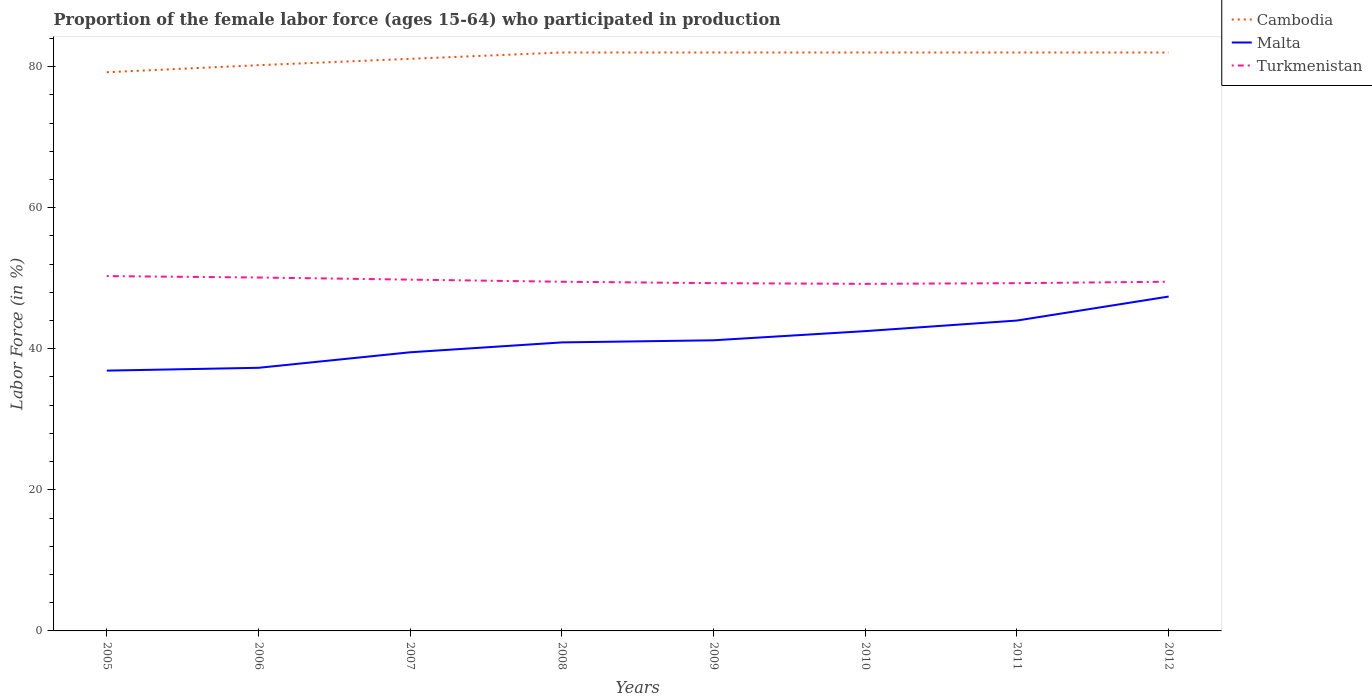How many different coloured lines are there?
Provide a succinct answer. 3. Across all years, what is the maximum proportion of the female labor force who participated in production in Malta?
Provide a short and direct response. 36.9. What is the total proportion of the female labor force who participated in production in Malta in the graph?
Your response must be concise. -1.5. What is the difference between the highest and the second highest proportion of the female labor force who participated in production in Malta?
Your answer should be very brief. 10.5. How many years are there in the graph?
Your answer should be very brief. 8. Does the graph contain grids?
Your response must be concise. No. How are the legend labels stacked?
Provide a succinct answer. Vertical. What is the title of the graph?
Your answer should be very brief. Proportion of the female labor force (ages 15-64) who participated in production. Does "Nicaragua" appear as one of the legend labels in the graph?
Provide a succinct answer. No. What is the label or title of the Y-axis?
Your answer should be compact. Labor Force (in %). What is the Labor Force (in %) in Cambodia in 2005?
Make the answer very short. 79.2. What is the Labor Force (in %) in Malta in 2005?
Make the answer very short. 36.9. What is the Labor Force (in %) of Turkmenistan in 2005?
Your answer should be very brief. 50.3. What is the Labor Force (in %) of Cambodia in 2006?
Ensure brevity in your answer.  80.2. What is the Labor Force (in %) in Malta in 2006?
Provide a succinct answer. 37.3. What is the Labor Force (in %) of Turkmenistan in 2006?
Ensure brevity in your answer.  50.1. What is the Labor Force (in %) of Cambodia in 2007?
Ensure brevity in your answer.  81.1. What is the Labor Force (in %) of Malta in 2007?
Your response must be concise. 39.5. What is the Labor Force (in %) in Turkmenistan in 2007?
Your answer should be very brief. 49.8. What is the Labor Force (in %) in Malta in 2008?
Ensure brevity in your answer.  40.9. What is the Labor Force (in %) of Turkmenistan in 2008?
Your response must be concise. 49.5. What is the Labor Force (in %) of Cambodia in 2009?
Offer a very short reply. 82. What is the Labor Force (in %) of Malta in 2009?
Keep it short and to the point. 41.2. What is the Labor Force (in %) of Turkmenistan in 2009?
Give a very brief answer. 49.3. What is the Labor Force (in %) in Cambodia in 2010?
Your response must be concise. 82. What is the Labor Force (in %) of Malta in 2010?
Your answer should be very brief. 42.5. What is the Labor Force (in %) of Turkmenistan in 2010?
Provide a short and direct response. 49.2. What is the Labor Force (in %) of Cambodia in 2011?
Provide a short and direct response. 82. What is the Labor Force (in %) of Malta in 2011?
Give a very brief answer. 44. What is the Labor Force (in %) of Turkmenistan in 2011?
Offer a terse response. 49.3. What is the Labor Force (in %) in Cambodia in 2012?
Give a very brief answer. 82. What is the Labor Force (in %) in Malta in 2012?
Provide a succinct answer. 47.4. What is the Labor Force (in %) in Turkmenistan in 2012?
Make the answer very short. 49.5. Across all years, what is the maximum Labor Force (in %) of Cambodia?
Your answer should be very brief. 82. Across all years, what is the maximum Labor Force (in %) in Malta?
Your response must be concise. 47.4. Across all years, what is the maximum Labor Force (in %) of Turkmenistan?
Keep it short and to the point. 50.3. Across all years, what is the minimum Labor Force (in %) in Cambodia?
Provide a succinct answer. 79.2. Across all years, what is the minimum Labor Force (in %) of Malta?
Keep it short and to the point. 36.9. Across all years, what is the minimum Labor Force (in %) of Turkmenistan?
Give a very brief answer. 49.2. What is the total Labor Force (in %) of Cambodia in the graph?
Provide a short and direct response. 650.5. What is the total Labor Force (in %) of Malta in the graph?
Keep it short and to the point. 329.7. What is the total Labor Force (in %) of Turkmenistan in the graph?
Keep it short and to the point. 397. What is the difference between the Labor Force (in %) of Cambodia in 2005 and that in 2006?
Provide a short and direct response. -1. What is the difference between the Labor Force (in %) in Malta in 2005 and that in 2006?
Provide a short and direct response. -0.4. What is the difference between the Labor Force (in %) in Malta in 2005 and that in 2008?
Your answer should be compact. -4. What is the difference between the Labor Force (in %) of Cambodia in 2005 and that in 2009?
Your answer should be very brief. -2.8. What is the difference between the Labor Force (in %) of Turkmenistan in 2005 and that in 2009?
Make the answer very short. 1. What is the difference between the Labor Force (in %) in Cambodia in 2005 and that in 2010?
Your answer should be very brief. -2.8. What is the difference between the Labor Force (in %) of Malta in 2005 and that in 2010?
Offer a very short reply. -5.6. What is the difference between the Labor Force (in %) of Cambodia in 2005 and that in 2011?
Give a very brief answer. -2.8. What is the difference between the Labor Force (in %) of Malta in 2005 and that in 2011?
Provide a short and direct response. -7.1. What is the difference between the Labor Force (in %) in Malta in 2005 and that in 2012?
Your response must be concise. -10.5. What is the difference between the Labor Force (in %) of Malta in 2006 and that in 2007?
Make the answer very short. -2.2. What is the difference between the Labor Force (in %) of Malta in 2006 and that in 2009?
Provide a short and direct response. -3.9. What is the difference between the Labor Force (in %) of Malta in 2006 and that in 2010?
Make the answer very short. -5.2. What is the difference between the Labor Force (in %) of Turkmenistan in 2006 and that in 2010?
Give a very brief answer. 0.9. What is the difference between the Labor Force (in %) in Cambodia in 2006 and that in 2011?
Your answer should be very brief. -1.8. What is the difference between the Labor Force (in %) in Malta in 2006 and that in 2011?
Keep it short and to the point. -6.7. What is the difference between the Labor Force (in %) of Malta in 2006 and that in 2012?
Ensure brevity in your answer.  -10.1. What is the difference between the Labor Force (in %) of Cambodia in 2007 and that in 2008?
Offer a terse response. -0.9. What is the difference between the Labor Force (in %) of Cambodia in 2007 and that in 2009?
Offer a terse response. -0.9. What is the difference between the Labor Force (in %) in Cambodia in 2007 and that in 2010?
Ensure brevity in your answer.  -0.9. What is the difference between the Labor Force (in %) of Malta in 2007 and that in 2010?
Provide a short and direct response. -3. What is the difference between the Labor Force (in %) in Turkmenistan in 2007 and that in 2010?
Keep it short and to the point. 0.6. What is the difference between the Labor Force (in %) in Cambodia in 2007 and that in 2011?
Your answer should be compact. -0.9. What is the difference between the Labor Force (in %) in Malta in 2007 and that in 2011?
Ensure brevity in your answer.  -4.5. What is the difference between the Labor Force (in %) in Turkmenistan in 2007 and that in 2011?
Make the answer very short. 0.5. What is the difference between the Labor Force (in %) of Cambodia in 2007 and that in 2012?
Offer a very short reply. -0.9. What is the difference between the Labor Force (in %) in Malta in 2007 and that in 2012?
Make the answer very short. -7.9. What is the difference between the Labor Force (in %) of Turkmenistan in 2007 and that in 2012?
Provide a succinct answer. 0.3. What is the difference between the Labor Force (in %) of Cambodia in 2008 and that in 2009?
Offer a terse response. 0. What is the difference between the Labor Force (in %) in Malta in 2008 and that in 2009?
Your answer should be compact. -0.3. What is the difference between the Labor Force (in %) in Turkmenistan in 2008 and that in 2009?
Your response must be concise. 0.2. What is the difference between the Labor Force (in %) in Cambodia in 2008 and that in 2010?
Offer a very short reply. 0. What is the difference between the Labor Force (in %) in Malta in 2008 and that in 2010?
Provide a succinct answer. -1.6. What is the difference between the Labor Force (in %) in Cambodia in 2008 and that in 2011?
Your answer should be compact. 0. What is the difference between the Labor Force (in %) in Malta in 2008 and that in 2011?
Your response must be concise. -3.1. What is the difference between the Labor Force (in %) of Turkmenistan in 2008 and that in 2011?
Make the answer very short. 0.2. What is the difference between the Labor Force (in %) of Malta in 2008 and that in 2012?
Make the answer very short. -6.5. What is the difference between the Labor Force (in %) of Cambodia in 2009 and that in 2010?
Keep it short and to the point. 0. What is the difference between the Labor Force (in %) of Malta in 2009 and that in 2010?
Your response must be concise. -1.3. What is the difference between the Labor Force (in %) of Malta in 2009 and that in 2011?
Your answer should be very brief. -2.8. What is the difference between the Labor Force (in %) in Cambodia in 2009 and that in 2012?
Offer a very short reply. 0. What is the difference between the Labor Force (in %) of Malta in 2009 and that in 2012?
Offer a terse response. -6.2. What is the difference between the Labor Force (in %) of Turkmenistan in 2009 and that in 2012?
Your response must be concise. -0.2. What is the difference between the Labor Force (in %) of Turkmenistan in 2010 and that in 2011?
Provide a succinct answer. -0.1. What is the difference between the Labor Force (in %) of Cambodia in 2010 and that in 2012?
Give a very brief answer. 0. What is the difference between the Labor Force (in %) in Malta in 2011 and that in 2012?
Provide a short and direct response. -3.4. What is the difference between the Labor Force (in %) in Cambodia in 2005 and the Labor Force (in %) in Malta in 2006?
Ensure brevity in your answer.  41.9. What is the difference between the Labor Force (in %) of Cambodia in 2005 and the Labor Force (in %) of Turkmenistan in 2006?
Your response must be concise. 29.1. What is the difference between the Labor Force (in %) of Cambodia in 2005 and the Labor Force (in %) of Malta in 2007?
Offer a terse response. 39.7. What is the difference between the Labor Force (in %) of Cambodia in 2005 and the Labor Force (in %) of Turkmenistan in 2007?
Your answer should be compact. 29.4. What is the difference between the Labor Force (in %) of Malta in 2005 and the Labor Force (in %) of Turkmenistan in 2007?
Ensure brevity in your answer.  -12.9. What is the difference between the Labor Force (in %) in Cambodia in 2005 and the Labor Force (in %) in Malta in 2008?
Offer a terse response. 38.3. What is the difference between the Labor Force (in %) in Cambodia in 2005 and the Labor Force (in %) in Turkmenistan in 2008?
Make the answer very short. 29.7. What is the difference between the Labor Force (in %) of Cambodia in 2005 and the Labor Force (in %) of Malta in 2009?
Give a very brief answer. 38. What is the difference between the Labor Force (in %) of Cambodia in 2005 and the Labor Force (in %) of Turkmenistan in 2009?
Offer a terse response. 29.9. What is the difference between the Labor Force (in %) in Malta in 2005 and the Labor Force (in %) in Turkmenistan in 2009?
Keep it short and to the point. -12.4. What is the difference between the Labor Force (in %) of Cambodia in 2005 and the Labor Force (in %) of Malta in 2010?
Make the answer very short. 36.7. What is the difference between the Labor Force (in %) in Cambodia in 2005 and the Labor Force (in %) in Turkmenistan in 2010?
Provide a short and direct response. 30. What is the difference between the Labor Force (in %) in Cambodia in 2005 and the Labor Force (in %) in Malta in 2011?
Keep it short and to the point. 35.2. What is the difference between the Labor Force (in %) of Cambodia in 2005 and the Labor Force (in %) of Turkmenistan in 2011?
Offer a very short reply. 29.9. What is the difference between the Labor Force (in %) in Cambodia in 2005 and the Labor Force (in %) in Malta in 2012?
Make the answer very short. 31.8. What is the difference between the Labor Force (in %) of Cambodia in 2005 and the Labor Force (in %) of Turkmenistan in 2012?
Offer a very short reply. 29.7. What is the difference between the Labor Force (in %) of Malta in 2005 and the Labor Force (in %) of Turkmenistan in 2012?
Offer a very short reply. -12.6. What is the difference between the Labor Force (in %) of Cambodia in 2006 and the Labor Force (in %) of Malta in 2007?
Offer a very short reply. 40.7. What is the difference between the Labor Force (in %) in Cambodia in 2006 and the Labor Force (in %) in Turkmenistan in 2007?
Make the answer very short. 30.4. What is the difference between the Labor Force (in %) in Malta in 2006 and the Labor Force (in %) in Turkmenistan in 2007?
Offer a terse response. -12.5. What is the difference between the Labor Force (in %) in Cambodia in 2006 and the Labor Force (in %) in Malta in 2008?
Make the answer very short. 39.3. What is the difference between the Labor Force (in %) of Cambodia in 2006 and the Labor Force (in %) of Turkmenistan in 2008?
Provide a short and direct response. 30.7. What is the difference between the Labor Force (in %) in Malta in 2006 and the Labor Force (in %) in Turkmenistan in 2008?
Offer a terse response. -12.2. What is the difference between the Labor Force (in %) of Cambodia in 2006 and the Labor Force (in %) of Malta in 2009?
Give a very brief answer. 39. What is the difference between the Labor Force (in %) of Cambodia in 2006 and the Labor Force (in %) of Turkmenistan in 2009?
Ensure brevity in your answer.  30.9. What is the difference between the Labor Force (in %) in Cambodia in 2006 and the Labor Force (in %) in Malta in 2010?
Make the answer very short. 37.7. What is the difference between the Labor Force (in %) of Cambodia in 2006 and the Labor Force (in %) of Malta in 2011?
Offer a very short reply. 36.2. What is the difference between the Labor Force (in %) in Cambodia in 2006 and the Labor Force (in %) in Turkmenistan in 2011?
Give a very brief answer. 30.9. What is the difference between the Labor Force (in %) of Cambodia in 2006 and the Labor Force (in %) of Malta in 2012?
Give a very brief answer. 32.8. What is the difference between the Labor Force (in %) of Cambodia in 2006 and the Labor Force (in %) of Turkmenistan in 2012?
Your response must be concise. 30.7. What is the difference between the Labor Force (in %) of Malta in 2006 and the Labor Force (in %) of Turkmenistan in 2012?
Your response must be concise. -12.2. What is the difference between the Labor Force (in %) of Cambodia in 2007 and the Labor Force (in %) of Malta in 2008?
Provide a succinct answer. 40.2. What is the difference between the Labor Force (in %) in Cambodia in 2007 and the Labor Force (in %) in Turkmenistan in 2008?
Your response must be concise. 31.6. What is the difference between the Labor Force (in %) of Cambodia in 2007 and the Labor Force (in %) of Malta in 2009?
Your answer should be very brief. 39.9. What is the difference between the Labor Force (in %) in Cambodia in 2007 and the Labor Force (in %) in Turkmenistan in 2009?
Provide a short and direct response. 31.8. What is the difference between the Labor Force (in %) in Malta in 2007 and the Labor Force (in %) in Turkmenistan in 2009?
Your answer should be compact. -9.8. What is the difference between the Labor Force (in %) in Cambodia in 2007 and the Labor Force (in %) in Malta in 2010?
Your response must be concise. 38.6. What is the difference between the Labor Force (in %) in Cambodia in 2007 and the Labor Force (in %) in Turkmenistan in 2010?
Keep it short and to the point. 31.9. What is the difference between the Labor Force (in %) of Malta in 2007 and the Labor Force (in %) of Turkmenistan in 2010?
Offer a terse response. -9.7. What is the difference between the Labor Force (in %) in Cambodia in 2007 and the Labor Force (in %) in Malta in 2011?
Your answer should be compact. 37.1. What is the difference between the Labor Force (in %) of Cambodia in 2007 and the Labor Force (in %) of Turkmenistan in 2011?
Give a very brief answer. 31.8. What is the difference between the Labor Force (in %) in Malta in 2007 and the Labor Force (in %) in Turkmenistan in 2011?
Give a very brief answer. -9.8. What is the difference between the Labor Force (in %) in Cambodia in 2007 and the Labor Force (in %) in Malta in 2012?
Offer a very short reply. 33.7. What is the difference between the Labor Force (in %) of Cambodia in 2007 and the Labor Force (in %) of Turkmenistan in 2012?
Provide a succinct answer. 31.6. What is the difference between the Labor Force (in %) in Cambodia in 2008 and the Labor Force (in %) in Malta in 2009?
Make the answer very short. 40.8. What is the difference between the Labor Force (in %) in Cambodia in 2008 and the Labor Force (in %) in Turkmenistan in 2009?
Ensure brevity in your answer.  32.7. What is the difference between the Labor Force (in %) in Cambodia in 2008 and the Labor Force (in %) in Malta in 2010?
Your response must be concise. 39.5. What is the difference between the Labor Force (in %) of Cambodia in 2008 and the Labor Force (in %) of Turkmenistan in 2010?
Ensure brevity in your answer.  32.8. What is the difference between the Labor Force (in %) in Malta in 2008 and the Labor Force (in %) in Turkmenistan in 2010?
Offer a very short reply. -8.3. What is the difference between the Labor Force (in %) of Cambodia in 2008 and the Labor Force (in %) of Turkmenistan in 2011?
Give a very brief answer. 32.7. What is the difference between the Labor Force (in %) in Malta in 2008 and the Labor Force (in %) in Turkmenistan in 2011?
Keep it short and to the point. -8.4. What is the difference between the Labor Force (in %) in Cambodia in 2008 and the Labor Force (in %) in Malta in 2012?
Provide a succinct answer. 34.6. What is the difference between the Labor Force (in %) of Cambodia in 2008 and the Labor Force (in %) of Turkmenistan in 2012?
Provide a short and direct response. 32.5. What is the difference between the Labor Force (in %) of Malta in 2008 and the Labor Force (in %) of Turkmenistan in 2012?
Provide a succinct answer. -8.6. What is the difference between the Labor Force (in %) of Cambodia in 2009 and the Labor Force (in %) of Malta in 2010?
Keep it short and to the point. 39.5. What is the difference between the Labor Force (in %) in Cambodia in 2009 and the Labor Force (in %) in Turkmenistan in 2010?
Ensure brevity in your answer.  32.8. What is the difference between the Labor Force (in %) of Malta in 2009 and the Labor Force (in %) of Turkmenistan in 2010?
Make the answer very short. -8. What is the difference between the Labor Force (in %) of Cambodia in 2009 and the Labor Force (in %) of Turkmenistan in 2011?
Give a very brief answer. 32.7. What is the difference between the Labor Force (in %) of Malta in 2009 and the Labor Force (in %) of Turkmenistan in 2011?
Make the answer very short. -8.1. What is the difference between the Labor Force (in %) in Cambodia in 2009 and the Labor Force (in %) in Malta in 2012?
Ensure brevity in your answer.  34.6. What is the difference between the Labor Force (in %) of Cambodia in 2009 and the Labor Force (in %) of Turkmenistan in 2012?
Your response must be concise. 32.5. What is the difference between the Labor Force (in %) of Cambodia in 2010 and the Labor Force (in %) of Malta in 2011?
Keep it short and to the point. 38. What is the difference between the Labor Force (in %) of Cambodia in 2010 and the Labor Force (in %) of Turkmenistan in 2011?
Offer a very short reply. 32.7. What is the difference between the Labor Force (in %) in Cambodia in 2010 and the Labor Force (in %) in Malta in 2012?
Keep it short and to the point. 34.6. What is the difference between the Labor Force (in %) of Cambodia in 2010 and the Labor Force (in %) of Turkmenistan in 2012?
Offer a very short reply. 32.5. What is the difference between the Labor Force (in %) of Cambodia in 2011 and the Labor Force (in %) of Malta in 2012?
Give a very brief answer. 34.6. What is the difference between the Labor Force (in %) of Cambodia in 2011 and the Labor Force (in %) of Turkmenistan in 2012?
Make the answer very short. 32.5. What is the average Labor Force (in %) in Cambodia per year?
Provide a succinct answer. 81.31. What is the average Labor Force (in %) in Malta per year?
Give a very brief answer. 41.21. What is the average Labor Force (in %) of Turkmenistan per year?
Make the answer very short. 49.62. In the year 2005, what is the difference between the Labor Force (in %) in Cambodia and Labor Force (in %) in Malta?
Provide a short and direct response. 42.3. In the year 2005, what is the difference between the Labor Force (in %) in Cambodia and Labor Force (in %) in Turkmenistan?
Offer a very short reply. 28.9. In the year 2005, what is the difference between the Labor Force (in %) of Malta and Labor Force (in %) of Turkmenistan?
Ensure brevity in your answer.  -13.4. In the year 2006, what is the difference between the Labor Force (in %) of Cambodia and Labor Force (in %) of Malta?
Your response must be concise. 42.9. In the year 2006, what is the difference between the Labor Force (in %) in Cambodia and Labor Force (in %) in Turkmenistan?
Your answer should be compact. 30.1. In the year 2006, what is the difference between the Labor Force (in %) of Malta and Labor Force (in %) of Turkmenistan?
Your answer should be very brief. -12.8. In the year 2007, what is the difference between the Labor Force (in %) in Cambodia and Labor Force (in %) in Malta?
Give a very brief answer. 41.6. In the year 2007, what is the difference between the Labor Force (in %) in Cambodia and Labor Force (in %) in Turkmenistan?
Provide a succinct answer. 31.3. In the year 2008, what is the difference between the Labor Force (in %) in Cambodia and Labor Force (in %) in Malta?
Offer a very short reply. 41.1. In the year 2008, what is the difference between the Labor Force (in %) of Cambodia and Labor Force (in %) of Turkmenistan?
Ensure brevity in your answer.  32.5. In the year 2009, what is the difference between the Labor Force (in %) in Cambodia and Labor Force (in %) in Malta?
Provide a succinct answer. 40.8. In the year 2009, what is the difference between the Labor Force (in %) of Cambodia and Labor Force (in %) of Turkmenistan?
Your response must be concise. 32.7. In the year 2009, what is the difference between the Labor Force (in %) of Malta and Labor Force (in %) of Turkmenistan?
Keep it short and to the point. -8.1. In the year 2010, what is the difference between the Labor Force (in %) in Cambodia and Labor Force (in %) in Malta?
Provide a short and direct response. 39.5. In the year 2010, what is the difference between the Labor Force (in %) of Cambodia and Labor Force (in %) of Turkmenistan?
Make the answer very short. 32.8. In the year 2010, what is the difference between the Labor Force (in %) of Malta and Labor Force (in %) of Turkmenistan?
Keep it short and to the point. -6.7. In the year 2011, what is the difference between the Labor Force (in %) of Cambodia and Labor Force (in %) of Turkmenistan?
Ensure brevity in your answer.  32.7. In the year 2011, what is the difference between the Labor Force (in %) in Malta and Labor Force (in %) in Turkmenistan?
Keep it short and to the point. -5.3. In the year 2012, what is the difference between the Labor Force (in %) of Cambodia and Labor Force (in %) of Malta?
Your response must be concise. 34.6. In the year 2012, what is the difference between the Labor Force (in %) of Cambodia and Labor Force (in %) of Turkmenistan?
Give a very brief answer. 32.5. In the year 2012, what is the difference between the Labor Force (in %) in Malta and Labor Force (in %) in Turkmenistan?
Your answer should be very brief. -2.1. What is the ratio of the Labor Force (in %) of Cambodia in 2005 to that in 2006?
Provide a short and direct response. 0.99. What is the ratio of the Labor Force (in %) in Malta in 2005 to that in 2006?
Provide a succinct answer. 0.99. What is the ratio of the Labor Force (in %) in Turkmenistan in 2005 to that in 2006?
Keep it short and to the point. 1. What is the ratio of the Labor Force (in %) of Cambodia in 2005 to that in 2007?
Your answer should be compact. 0.98. What is the ratio of the Labor Force (in %) in Malta in 2005 to that in 2007?
Provide a succinct answer. 0.93. What is the ratio of the Labor Force (in %) in Cambodia in 2005 to that in 2008?
Your response must be concise. 0.97. What is the ratio of the Labor Force (in %) in Malta in 2005 to that in 2008?
Your answer should be compact. 0.9. What is the ratio of the Labor Force (in %) of Turkmenistan in 2005 to that in 2008?
Make the answer very short. 1.02. What is the ratio of the Labor Force (in %) in Cambodia in 2005 to that in 2009?
Your answer should be very brief. 0.97. What is the ratio of the Labor Force (in %) of Malta in 2005 to that in 2009?
Provide a succinct answer. 0.9. What is the ratio of the Labor Force (in %) in Turkmenistan in 2005 to that in 2009?
Provide a short and direct response. 1.02. What is the ratio of the Labor Force (in %) of Cambodia in 2005 to that in 2010?
Your response must be concise. 0.97. What is the ratio of the Labor Force (in %) of Malta in 2005 to that in 2010?
Your answer should be very brief. 0.87. What is the ratio of the Labor Force (in %) of Turkmenistan in 2005 to that in 2010?
Provide a succinct answer. 1.02. What is the ratio of the Labor Force (in %) of Cambodia in 2005 to that in 2011?
Your answer should be very brief. 0.97. What is the ratio of the Labor Force (in %) of Malta in 2005 to that in 2011?
Offer a very short reply. 0.84. What is the ratio of the Labor Force (in %) in Turkmenistan in 2005 to that in 2011?
Keep it short and to the point. 1.02. What is the ratio of the Labor Force (in %) in Cambodia in 2005 to that in 2012?
Give a very brief answer. 0.97. What is the ratio of the Labor Force (in %) of Malta in 2005 to that in 2012?
Ensure brevity in your answer.  0.78. What is the ratio of the Labor Force (in %) of Turkmenistan in 2005 to that in 2012?
Keep it short and to the point. 1.02. What is the ratio of the Labor Force (in %) of Cambodia in 2006 to that in 2007?
Ensure brevity in your answer.  0.99. What is the ratio of the Labor Force (in %) of Malta in 2006 to that in 2007?
Provide a short and direct response. 0.94. What is the ratio of the Labor Force (in %) in Cambodia in 2006 to that in 2008?
Provide a short and direct response. 0.98. What is the ratio of the Labor Force (in %) of Malta in 2006 to that in 2008?
Make the answer very short. 0.91. What is the ratio of the Labor Force (in %) in Turkmenistan in 2006 to that in 2008?
Your answer should be compact. 1.01. What is the ratio of the Labor Force (in %) in Cambodia in 2006 to that in 2009?
Offer a very short reply. 0.98. What is the ratio of the Labor Force (in %) of Malta in 2006 to that in 2009?
Provide a succinct answer. 0.91. What is the ratio of the Labor Force (in %) in Turkmenistan in 2006 to that in 2009?
Ensure brevity in your answer.  1.02. What is the ratio of the Labor Force (in %) in Malta in 2006 to that in 2010?
Offer a very short reply. 0.88. What is the ratio of the Labor Force (in %) of Turkmenistan in 2006 to that in 2010?
Give a very brief answer. 1.02. What is the ratio of the Labor Force (in %) of Cambodia in 2006 to that in 2011?
Your response must be concise. 0.98. What is the ratio of the Labor Force (in %) in Malta in 2006 to that in 2011?
Offer a very short reply. 0.85. What is the ratio of the Labor Force (in %) in Turkmenistan in 2006 to that in 2011?
Provide a succinct answer. 1.02. What is the ratio of the Labor Force (in %) of Malta in 2006 to that in 2012?
Keep it short and to the point. 0.79. What is the ratio of the Labor Force (in %) of Turkmenistan in 2006 to that in 2012?
Offer a very short reply. 1.01. What is the ratio of the Labor Force (in %) in Malta in 2007 to that in 2008?
Offer a very short reply. 0.97. What is the ratio of the Labor Force (in %) of Cambodia in 2007 to that in 2009?
Offer a terse response. 0.99. What is the ratio of the Labor Force (in %) of Malta in 2007 to that in 2009?
Your response must be concise. 0.96. What is the ratio of the Labor Force (in %) in Malta in 2007 to that in 2010?
Keep it short and to the point. 0.93. What is the ratio of the Labor Force (in %) of Turkmenistan in 2007 to that in 2010?
Make the answer very short. 1.01. What is the ratio of the Labor Force (in %) of Cambodia in 2007 to that in 2011?
Offer a very short reply. 0.99. What is the ratio of the Labor Force (in %) in Malta in 2007 to that in 2011?
Your answer should be compact. 0.9. What is the ratio of the Labor Force (in %) of Malta in 2007 to that in 2012?
Ensure brevity in your answer.  0.83. What is the ratio of the Labor Force (in %) in Cambodia in 2008 to that in 2009?
Provide a short and direct response. 1. What is the ratio of the Labor Force (in %) of Malta in 2008 to that in 2009?
Provide a succinct answer. 0.99. What is the ratio of the Labor Force (in %) in Malta in 2008 to that in 2010?
Your answer should be compact. 0.96. What is the ratio of the Labor Force (in %) in Turkmenistan in 2008 to that in 2010?
Ensure brevity in your answer.  1.01. What is the ratio of the Labor Force (in %) of Malta in 2008 to that in 2011?
Your response must be concise. 0.93. What is the ratio of the Labor Force (in %) in Malta in 2008 to that in 2012?
Offer a terse response. 0.86. What is the ratio of the Labor Force (in %) of Turkmenistan in 2008 to that in 2012?
Make the answer very short. 1. What is the ratio of the Labor Force (in %) in Cambodia in 2009 to that in 2010?
Offer a very short reply. 1. What is the ratio of the Labor Force (in %) in Malta in 2009 to that in 2010?
Your answer should be very brief. 0.97. What is the ratio of the Labor Force (in %) of Malta in 2009 to that in 2011?
Provide a short and direct response. 0.94. What is the ratio of the Labor Force (in %) in Cambodia in 2009 to that in 2012?
Your answer should be compact. 1. What is the ratio of the Labor Force (in %) in Malta in 2009 to that in 2012?
Your answer should be compact. 0.87. What is the ratio of the Labor Force (in %) of Turkmenistan in 2009 to that in 2012?
Offer a terse response. 1. What is the ratio of the Labor Force (in %) of Cambodia in 2010 to that in 2011?
Make the answer very short. 1. What is the ratio of the Labor Force (in %) in Malta in 2010 to that in 2011?
Keep it short and to the point. 0.97. What is the ratio of the Labor Force (in %) in Turkmenistan in 2010 to that in 2011?
Provide a short and direct response. 1. What is the ratio of the Labor Force (in %) in Malta in 2010 to that in 2012?
Give a very brief answer. 0.9. What is the ratio of the Labor Force (in %) of Cambodia in 2011 to that in 2012?
Make the answer very short. 1. What is the ratio of the Labor Force (in %) of Malta in 2011 to that in 2012?
Your response must be concise. 0.93. What is the difference between the highest and the second highest Labor Force (in %) of Cambodia?
Keep it short and to the point. 0. What is the difference between the highest and the second highest Labor Force (in %) of Malta?
Your answer should be very brief. 3.4. 